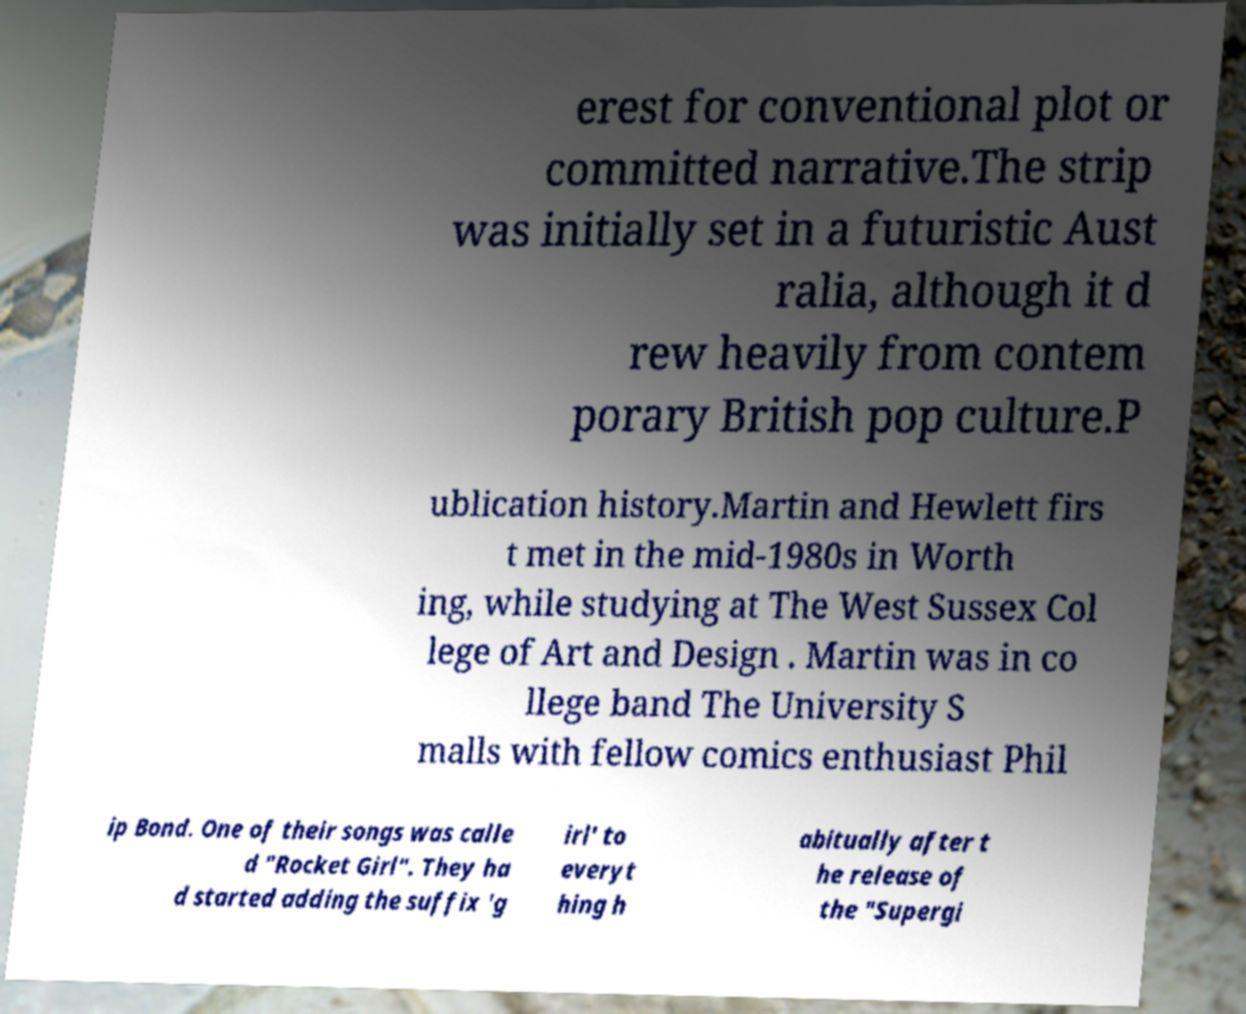For documentation purposes, I need the text within this image transcribed. Could you provide that? erest for conventional plot or committed narrative.The strip was initially set in a futuristic Aust ralia, although it d rew heavily from contem porary British pop culture.P ublication history.Martin and Hewlett firs t met in the mid-1980s in Worth ing, while studying at The West Sussex Col lege of Art and Design . Martin was in co llege band The University S malls with fellow comics enthusiast Phil ip Bond. One of their songs was calle d "Rocket Girl". They ha d started adding the suffix 'g irl' to everyt hing h abitually after t he release of the "Supergi 